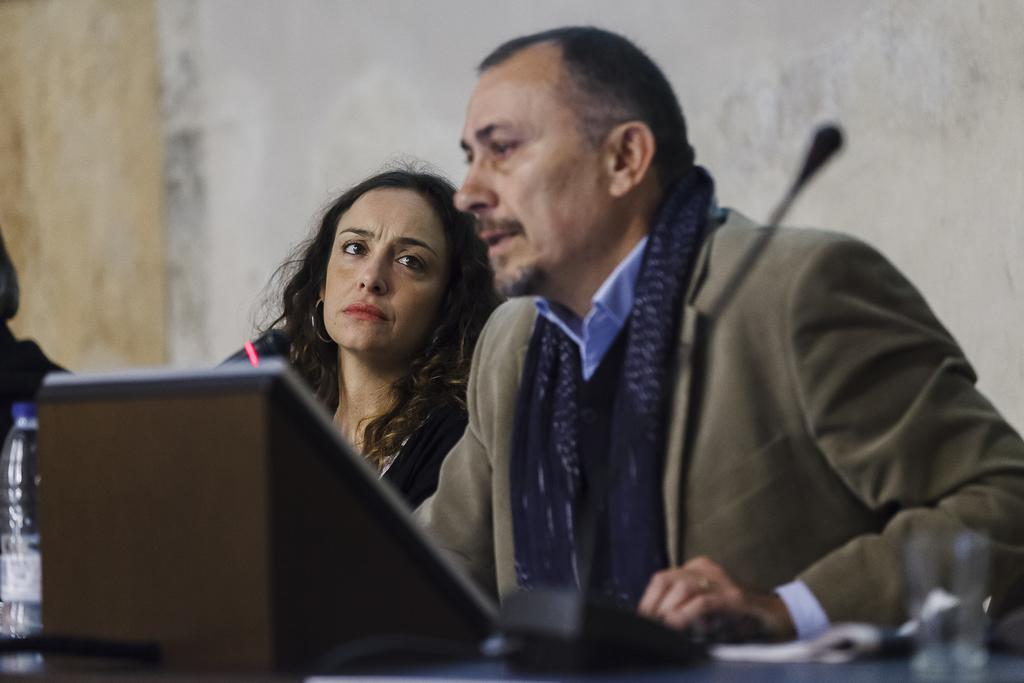What is happening in the image involving a group of people? There is a group of people in the image, and they are seated. What objects are in front of the seated people? There are microphones in front of the people. What can be seen on the table in the image? There is a bottle on the table. What type of company is being discussed by the people in the image? There is no indication in the image that the people are discussing a company, so it cannot be determined from the picture. 